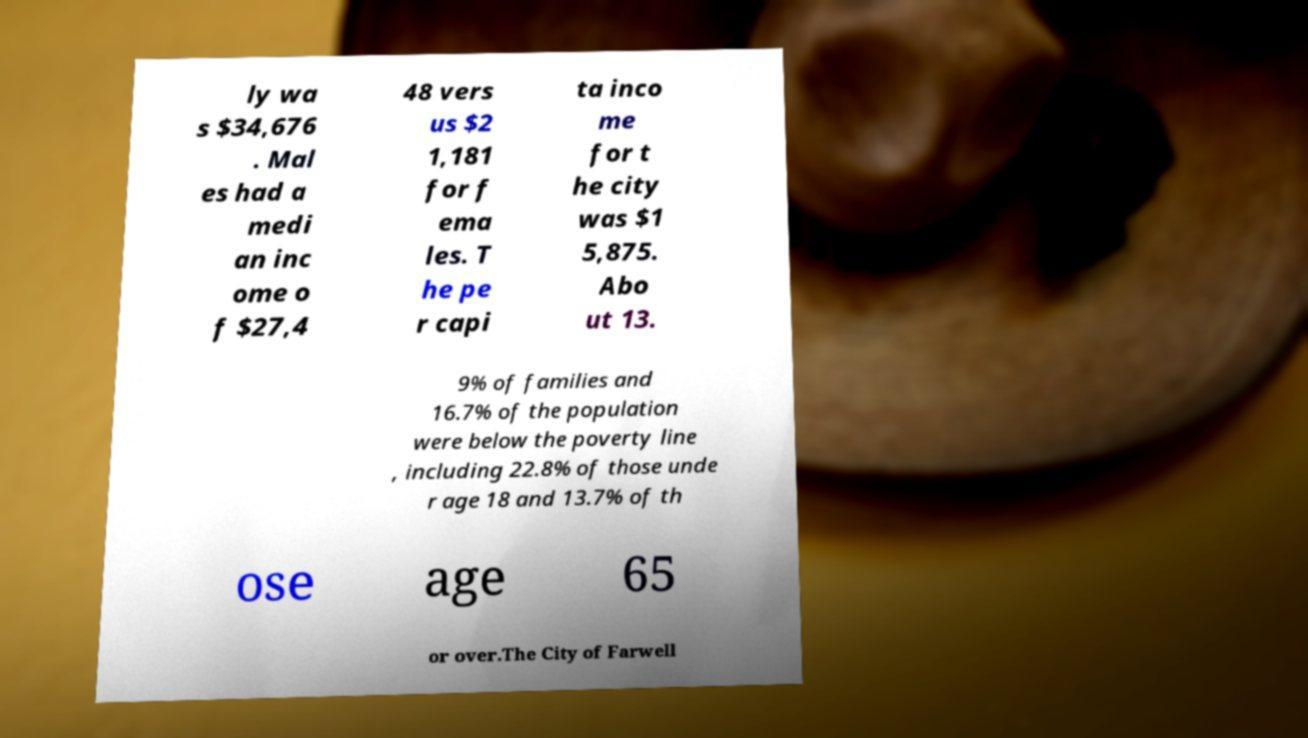There's text embedded in this image that I need extracted. Can you transcribe it verbatim? ly wa s $34,676 . Mal es had a medi an inc ome o f $27,4 48 vers us $2 1,181 for f ema les. T he pe r capi ta inco me for t he city was $1 5,875. Abo ut 13. 9% of families and 16.7% of the population were below the poverty line , including 22.8% of those unde r age 18 and 13.7% of th ose age 65 or over.The City of Farwell 